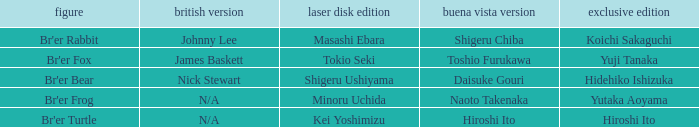Who is the buena vista edidtion where special edition is koichi sakaguchi? Shigeru Chiba. 